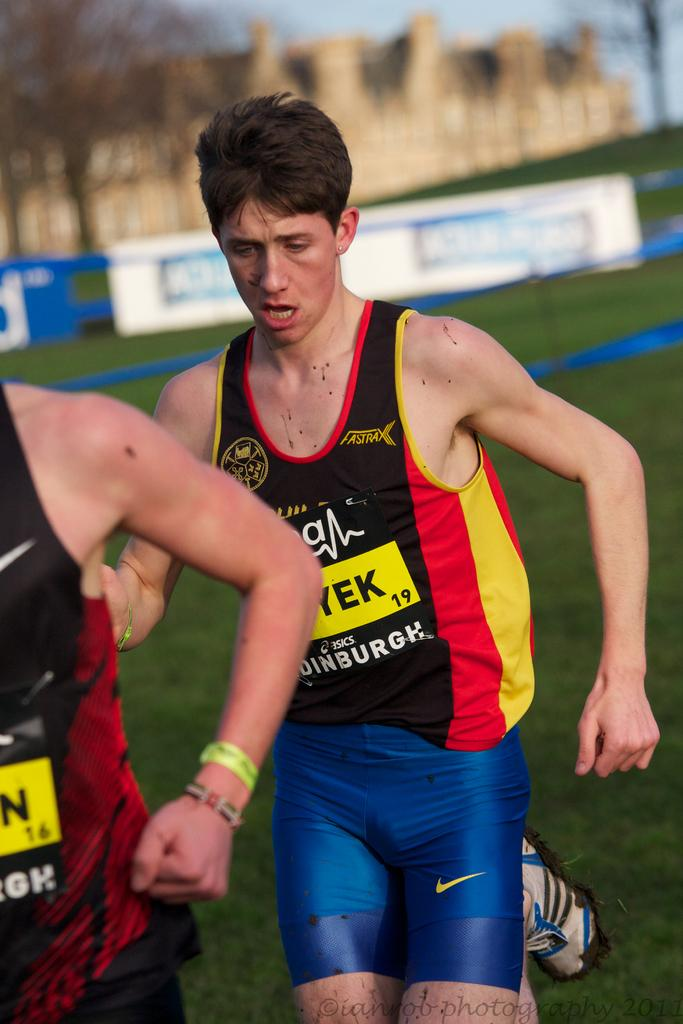<image>
Create a compact narrative representing the image presented. a runner that has the number 19 on him 